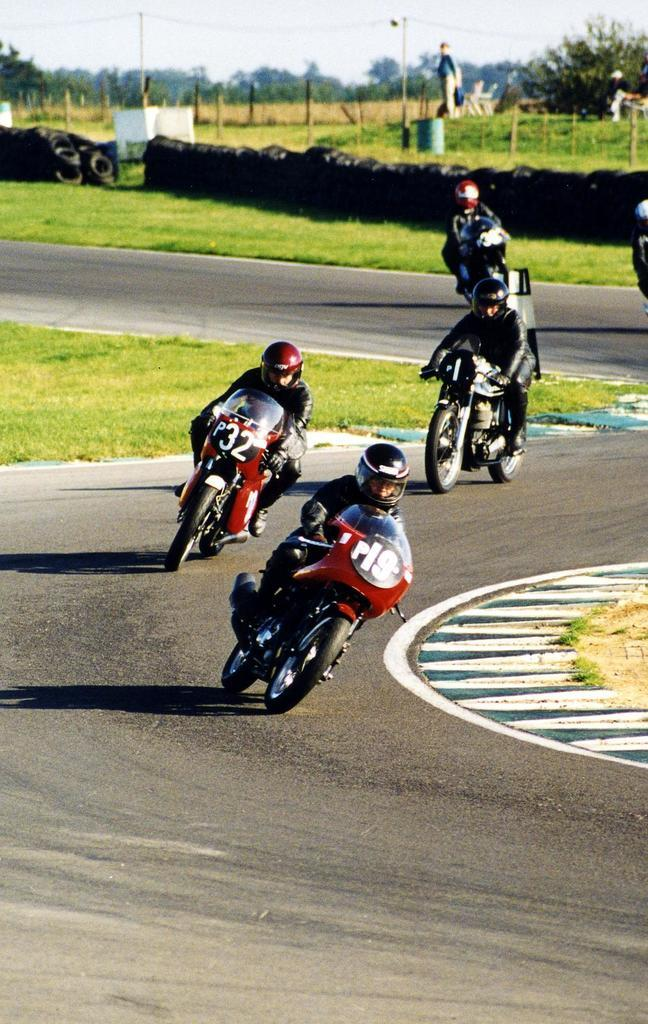What are the persons in the image doing? The persons in the image are on bikes. What type of location is depicted in the image? This is a road in the image. What type of vegetation can be seen in the image? There is grass visible in the image. What can be seen in the background of the image? There are trees and the sky visible in the background of the image. Can you tell me how many goldfish are swimming in the image? There are no goldfish present in the image; it features persons on bikes on a road with grass, trees, and the sky visible in the background. 